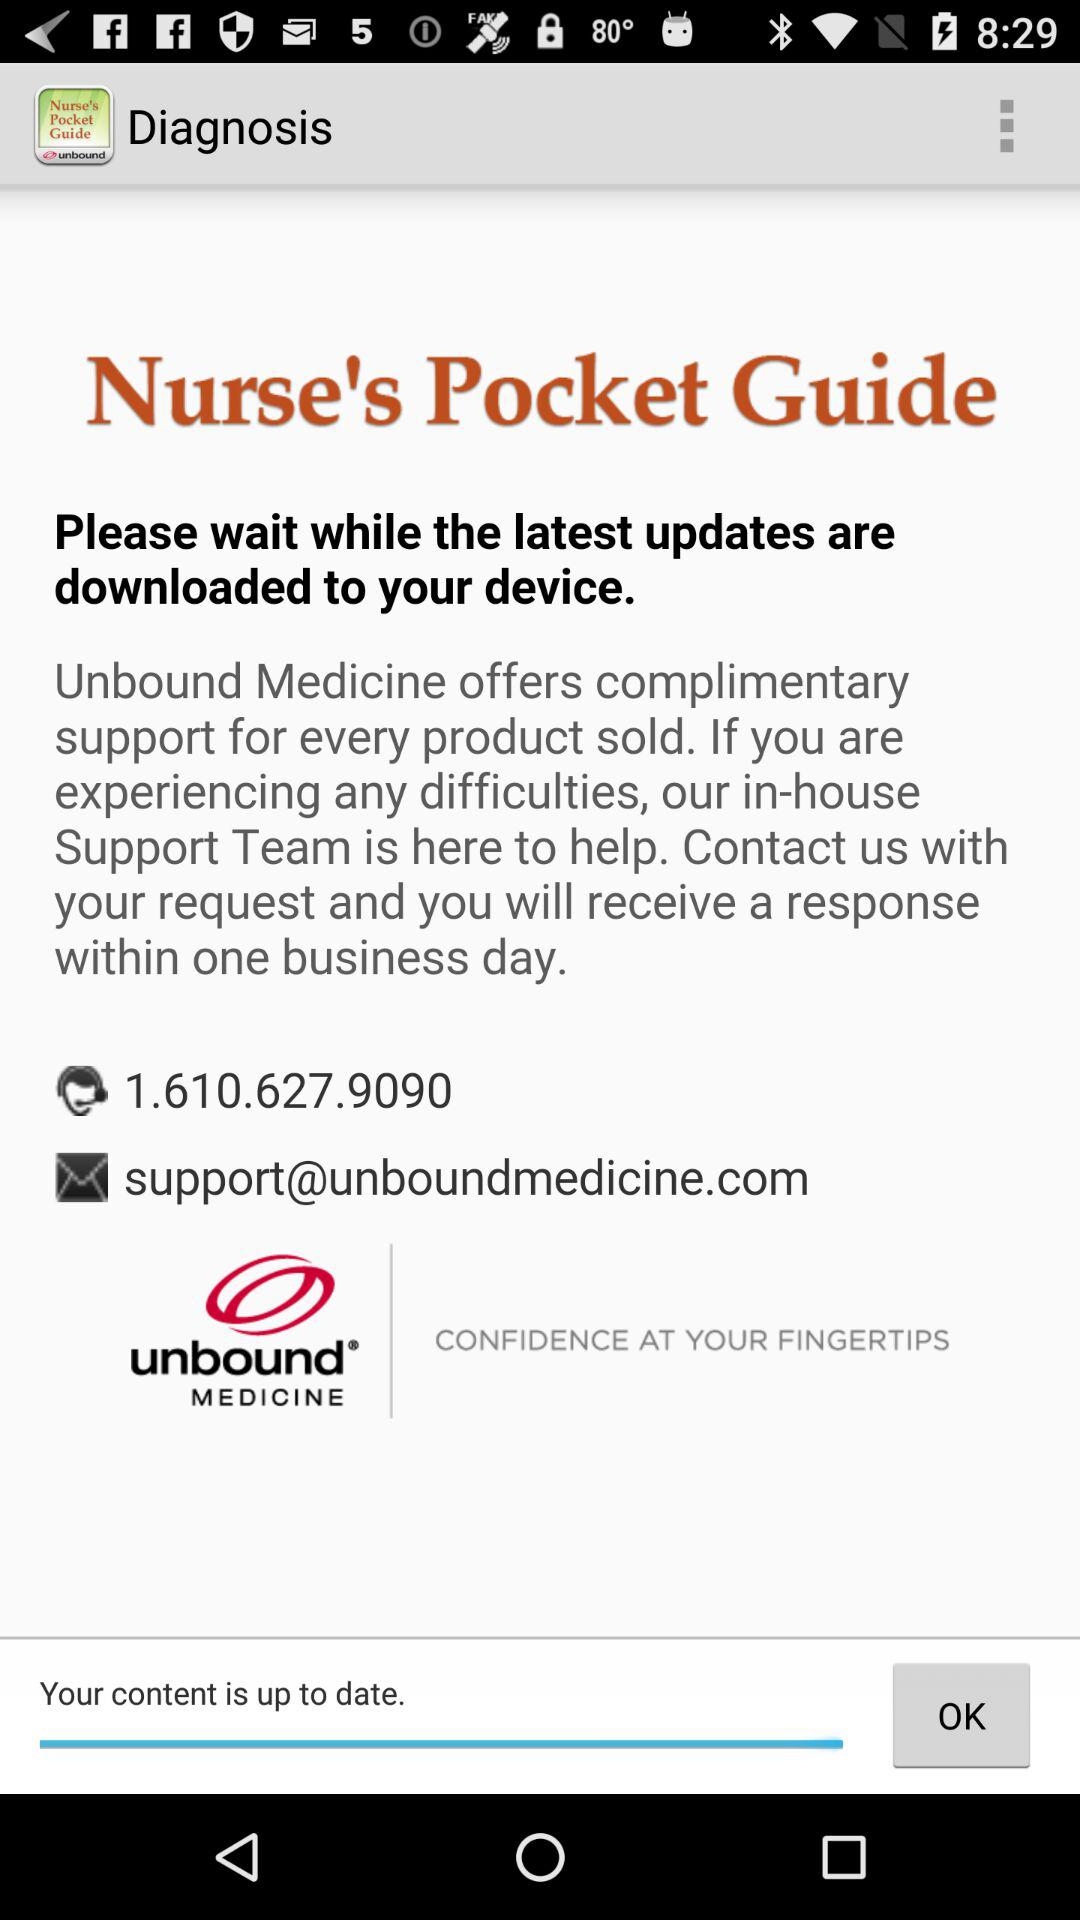What is the version of "Diagnosis" that is being used?
When the provided information is insufficient, respond with <no answer>. <no answer> 